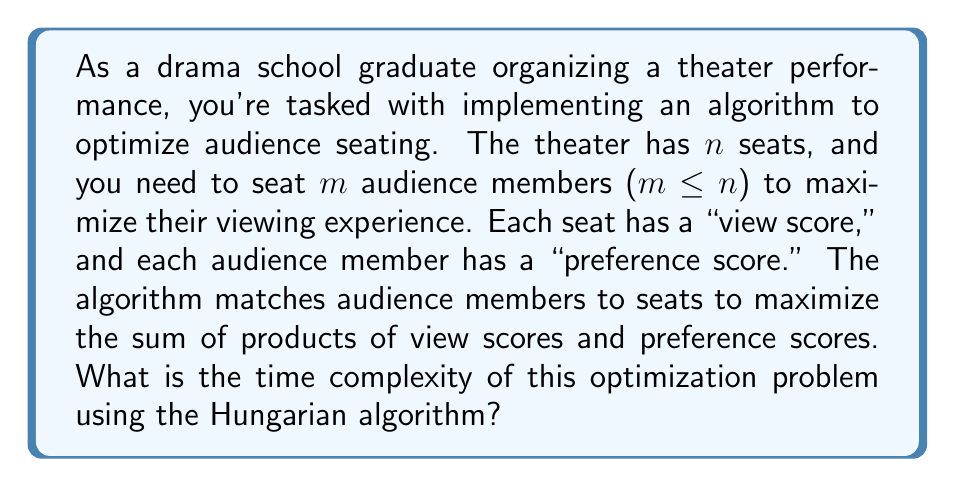What is the answer to this math problem? To solve this problem, we can model it as a maximum weight bipartite matching problem, which can be solved using the Hungarian algorithm. Let's break down the analysis:

1. Problem setup:
   - We have $n$ seats and $m$ audience members.
   - We create a bipartite graph with $n$ nodes on one side (seats) and $m$ nodes on the other side (audience members).
   - Each edge $(i,j)$ has a weight $w_{ij} = v_i \times p_j$, where $v_i$ is the view score of seat $i$ and $p_j$ is the preference score of audience member $j$.

2. Hungarian algorithm complexity:
   - The Hungarian algorithm has a time complexity of $O(n^3)$ for an $n \times n$ matrix.
   - In our case, we have an $n \times m$ matrix, where $m \leq n$.

3. Adjusting for our scenario:
   - We need to ensure our matrix is square, so we add $(n-m)$ dummy audience members with zero preference scores.
   - This gives us an $n \times n$ matrix.

4. Running the Hungarian algorithm:
   - On this $n \times n$ matrix, the time complexity is $O(n^3)$.

5. Additional considerations:
   - Creating the weight matrix takes $O(n^2)$ time.
   - This is dominated by the $O(n^3)$ complexity of the Hungarian algorithm.

Therefore, the overall time complexity of the audience seating optimization algorithm using the Hungarian method is $O(n^3)$, where $n$ is the number of seats in the theater.
Answer: $O(n^3)$, where $n$ is the number of seats in the theater. 